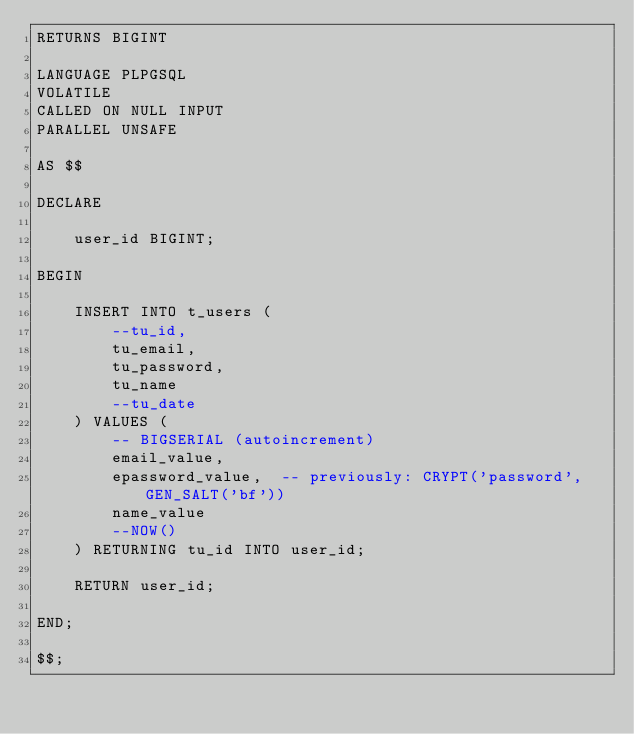<code> <loc_0><loc_0><loc_500><loc_500><_SQL_>RETURNS BIGINT

LANGUAGE PLPGSQL
VOLATILE
CALLED ON NULL INPUT
PARALLEL UNSAFE

AS $$

DECLARE

    user_id BIGINT;

BEGIN

    INSERT INTO t_users (
        --tu_id,
        tu_email,
        tu_password,
        tu_name
        --tu_date
    ) VALUES (
        -- BIGSERIAL (autoincrement)
        email_value,
        epassword_value,  -- previously: CRYPT('password', GEN_SALT('bf'))
        name_value
        --NOW()
    ) RETURNING tu_id INTO user_id;

    RETURN user_id;

END;

$$;
</code> 